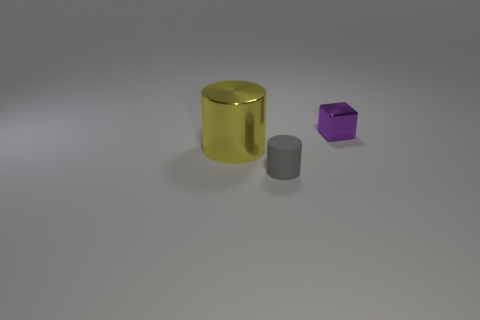Can you tell me the possible function of the yellow cylinder? Given its simplistic design and the absence of additional context, the yellow cylinder might be a decorative piece, part of a children's toy set, or a placeholder object in a 3D rendering. Its function is not immediately clear from the image alone. 